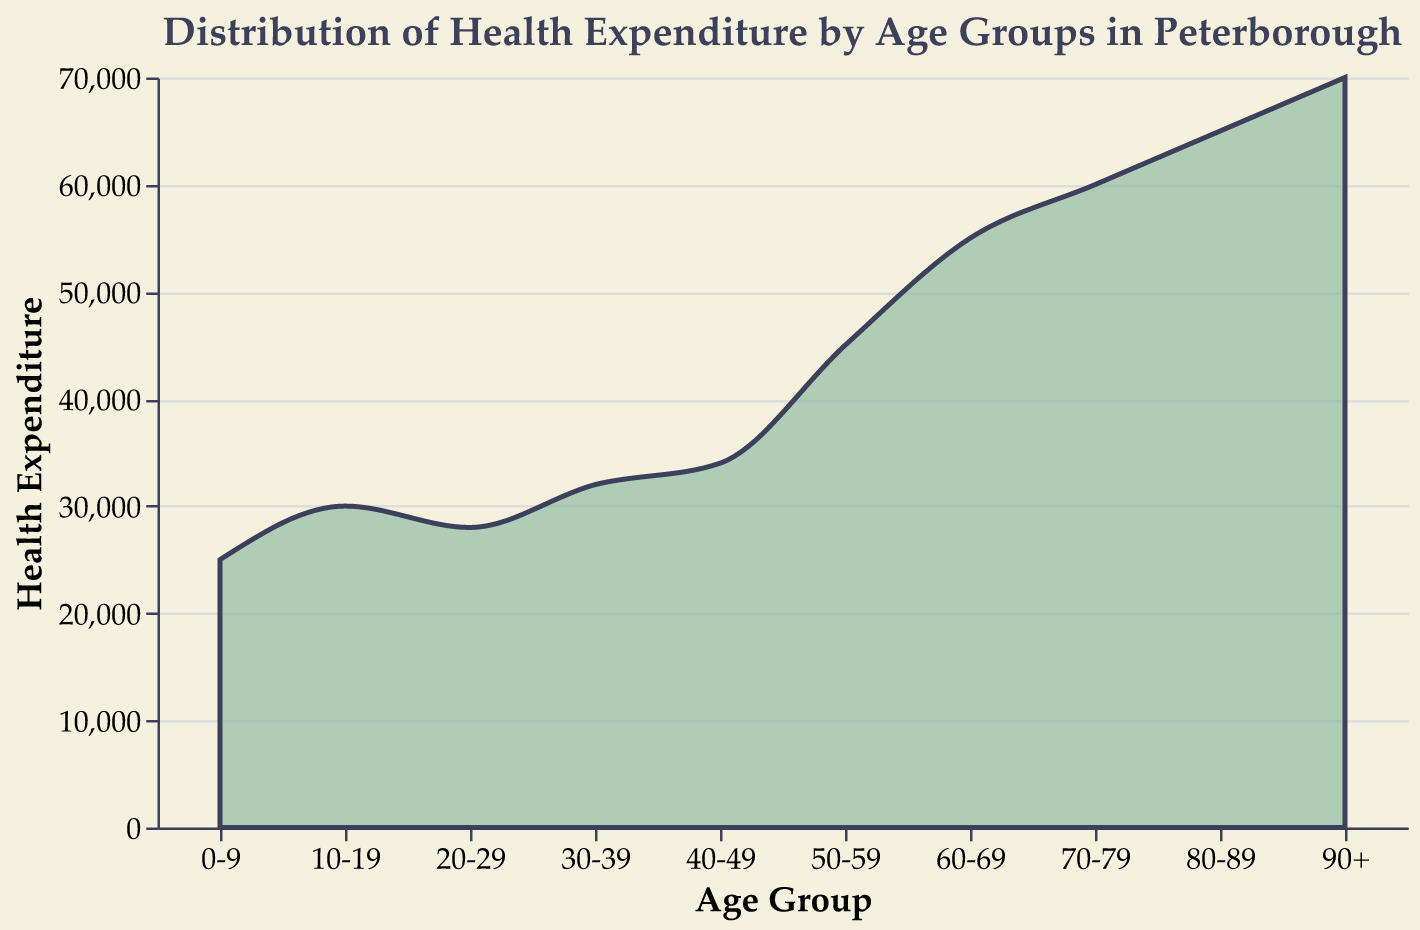What is the title of the figure? The title is usually located at the top of the figure, which gives an overview of what the plot represents. Here, the title is "Distribution of Health Expenditure by Age Groups in Peterborough" as specified in the code.
Answer: Distribution of Health Expenditure by Age Groups in Peterborough What is the health expenditure for the age group 60-69? To find the health expenditure for a specific age group, we look at the height of the area under the line corresponding to that age group. For the age group 60-69, it is given as 55000.
Answer: 55000 Which age group has the highest health expenditure? Reviewing the plot, the highest point corresponds to the age group 90+, indicating the highest expenditure. Referring to the data, the expenditure is 70000.
Answer: 90+ How does the health expenditure change as age increases? Observing the trend in the plot, we notice a general increase in health expenditure with each subsequent age group. Starting from 0-9 to 90+, the expenditure continuously rises.
Answer: It increases Is the expenditure for age group 40-49 higher or lower than for age group 50-59? By comparing the height of the area under the curve for the two groups, the expenditure for age group 40-49 (34000) is observed to be lower than for age group 50-59 (45000).
Answer: Lower What is the average health expenditure for the age groups from 0-9 to 40-49? Sum the expenditures for 0-9, 10-19, 20-29, 30-39, and 40-49: (25000 + 30000 + 28000 + 32000 + 34000) = 149000. There are 5 age groups, so the average is 149000 / 5 = 29800.
Answer: 29800 What is the difference in health expenditure between the age groups 70-79 and 80-89? Subtract the expenditure for 70-79 from that of 80-89: 65000 - 60000 = 5000.
Answer: 5000 Which age group experiences a more significant increase in health expenditure compared to the previous group, 50-59 or 60-69? Calculate the increases: from 40-49 to 50-59 is 45000 - 34000 = 11000, and from 50-59 to 60-69 is 55000 - 45000 = 10000. The increase from 40-49 to 50-59 is larger.
Answer: 50-59 What is the general trend depicted in the density plot? A density plot shows how data is distributed across different values. Here, the plot indicates that health expenditure tends to rise as age increases, forming a general upward trend.
Answer: Upward trend 